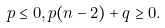<formula> <loc_0><loc_0><loc_500><loc_500>p \leq 0 , p ( n - 2 ) + q \geq 0 .</formula> 